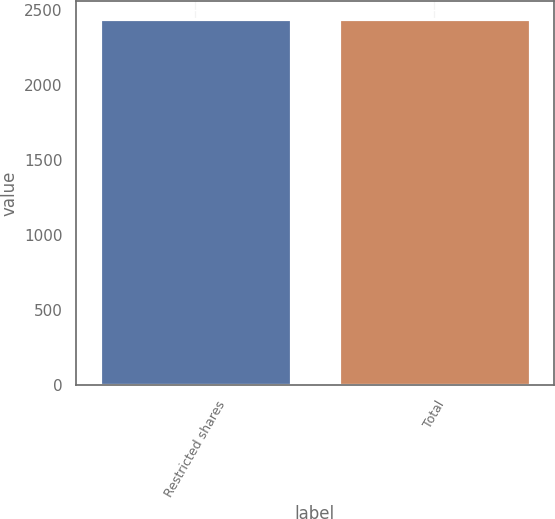<chart> <loc_0><loc_0><loc_500><loc_500><bar_chart><fcel>Restricted shares<fcel>Total<nl><fcel>2437<fcel>2437.1<nl></chart> 